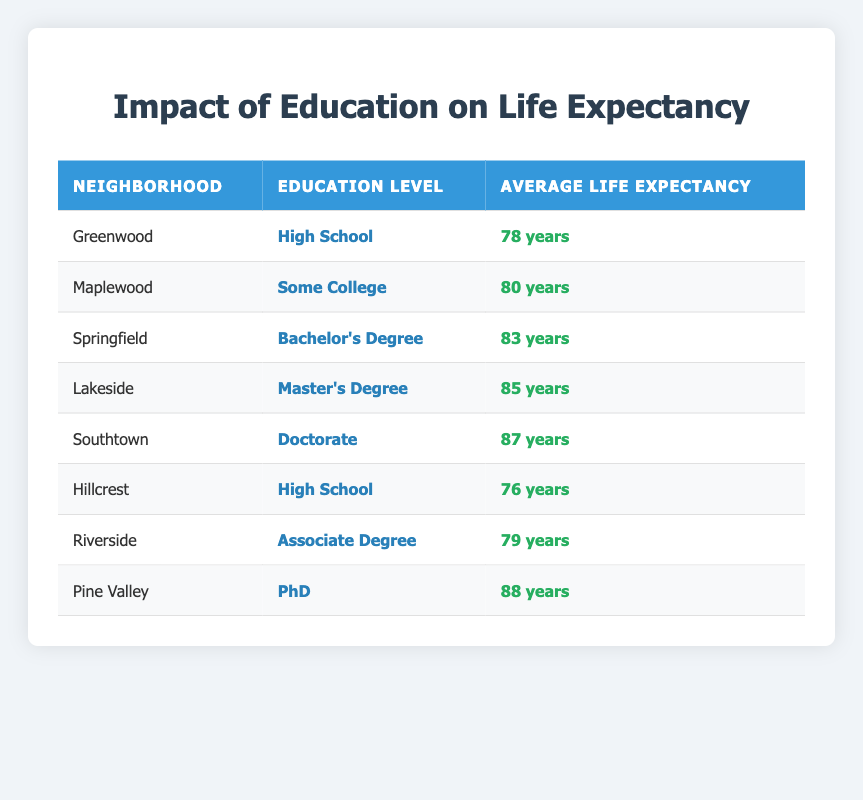What is the average life expectancy in Greenwood? The average life expectancy in Greenwood is listed in the table as 78 years.
Answer: 78 years Which neighborhood has the highest average life expectancy? The table shows that Pine Valley has the highest average life expectancy at 88 years.
Answer: Pine Valley Is the average life expectancy higher in neighborhoods with a Bachelor's Degree compared to those with a High School education? Looking at Springfield (83 years) with a Bachelor's Degree and Greenwood (78 years) and Hillcrest (76 years), both with High School education, we see that neighborhoods with Bachelor's Degrees have higher life expectancy: 83 years vs. 78 years and 76 years.
Answer: Yes What is the difference in average life expectancy between Southtown and Maplewood? Southtown has an average life expectancy of 87 years and Maplewood has 80 years. The difference is calculated as 87 - 80 = 7 years.
Answer: 7 years Is there a neighborhood with an average life expectancy of 82 years? By reviewing the table, the average life expectancy values listed are 76, 78, 79, 80, 83, 85, 87, and 88 years. None of these values equal 82 years.
Answer: No Which education level is associated with the lowest average life expectancy? The table indicates that both Greenwood and Hillcrest, which have a High School education level, have the lowest averages of 78 years and 76 years, respectively. Therefore, High School is associated with the lowest average life expectancy.
Answer: High School Calculate the average life expectancy for neighborhoods with a Master's Degree or higher. The table lists Lakeside (85 years), Southtown (87 years), and Pine Valley (88 years). Their sum is 85 + 87 + 88 = 260, and there are three data points. Choosing the average: 260 / 3 = 86.67, which we can round to 87 years.
Answer: 87 years Which neighborhood has a higher average life expectancy, Riverside or Maplewood? Riverside has an average life expectancy of 79 years, while Maplewood has an average of 80 years. Comparing these two values shows that Maplewood has a higher average life expectancy.
Answer: Maplewood How many neighborhoods have an average life expectancy of 80 years or more? The neighborhoods with 80 years or more are Maplewood (80), Springfield (83), Lakeside (85), Southtown (87), and Pine Valley (88). That totals five neighborhoods.
Answer: 5 neighborhoods 